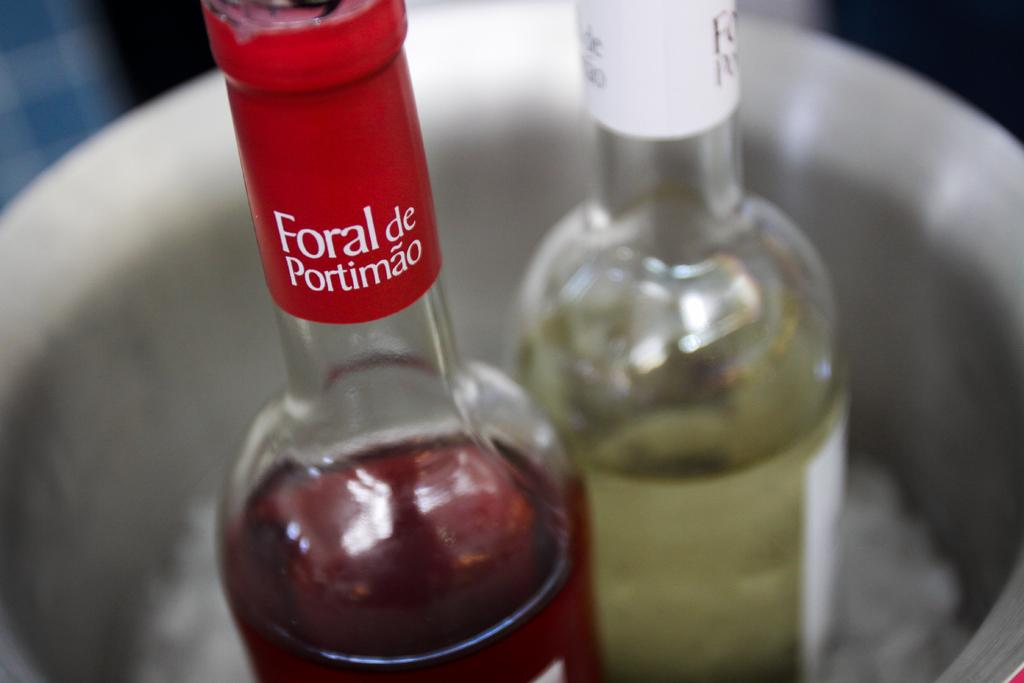<image>
Give a short and clear explanation of the subsequent image. A red and a white wine bottle sit in an ice bucket - the red wine is Foral de Portimao. 